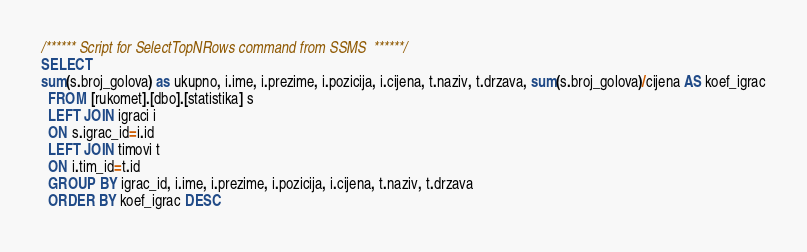<code> <loc_0><loc_0><loc_500><loc_500><_SQL_>/****** Script for SelectTopNRows command from SSMS  ******/
SELECT 
sum(s.broj_golova) as ukupno, i.ime, i.prezime, i.pozicija, i.cijena, t.naziv, t.drzava, sum(s.broj_golova)/cijena AS koef_igrac
  FROM [rukomet].[dbo].[statistika] s
  LEFT JOIN igraci i
  ON s.igrac_id=i.id
  LEFT JOIN timovi t
  ON i.tim_id=t.id
  GROUP BY igrac_id, i.ime, i.prezime, i.pozicija, i.cijena, t.naziv, t.drzava
  ORDER BY koef_igrac DESC</code> 